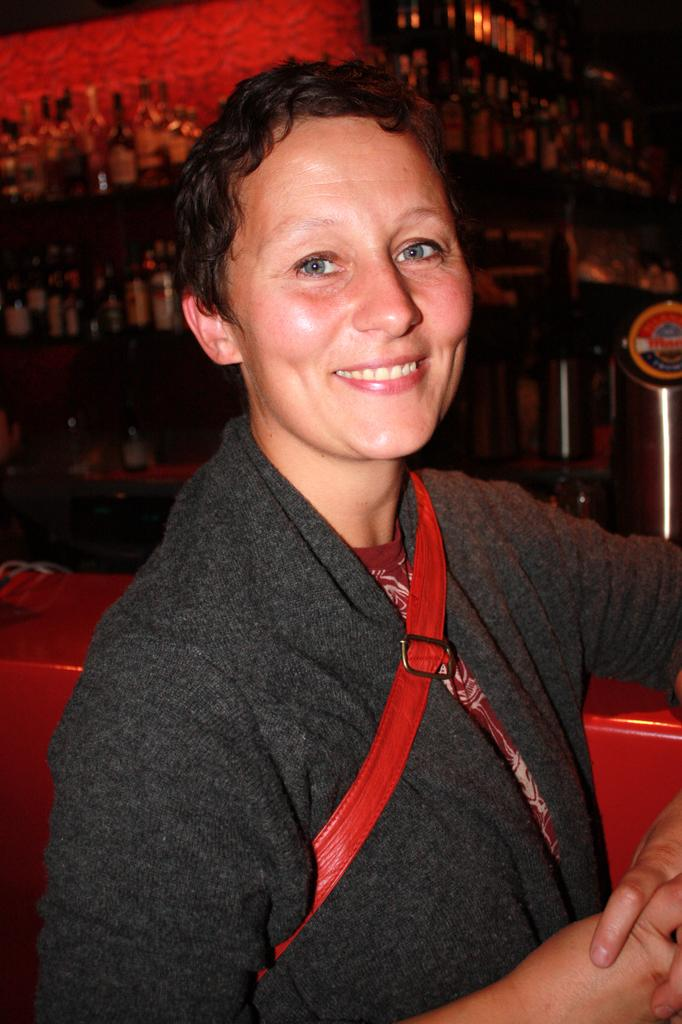Who or what is present in the image? There is a person in the image. What objects can be seen in the image besides the person? There are wine bottles in the image. How are the wine bottles arranged in the image? The wine bottles are kept in racks. What can be said about the lighting in the image? The background of the image is dark. What type of texture can be seen on the secretary's desk in the image? There is no secretary or desk present in the image. 